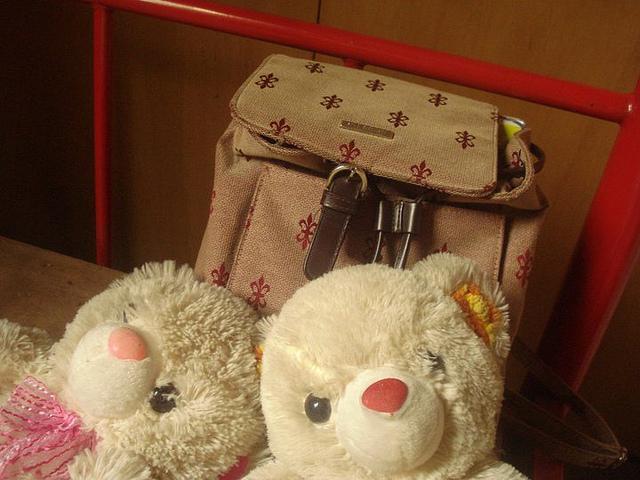How many stuffed animals are there?
Give a very brief answer. 2. How many white bears are in this scene?
Give a very brief answer. 2. How many teddy bears are visible?
Give a very brief answer. 2. 